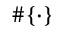Convert formula to latex. <formula><loc_0><loc_0><loc_500><loc_500>\# \{ \cdot \}</formula> 